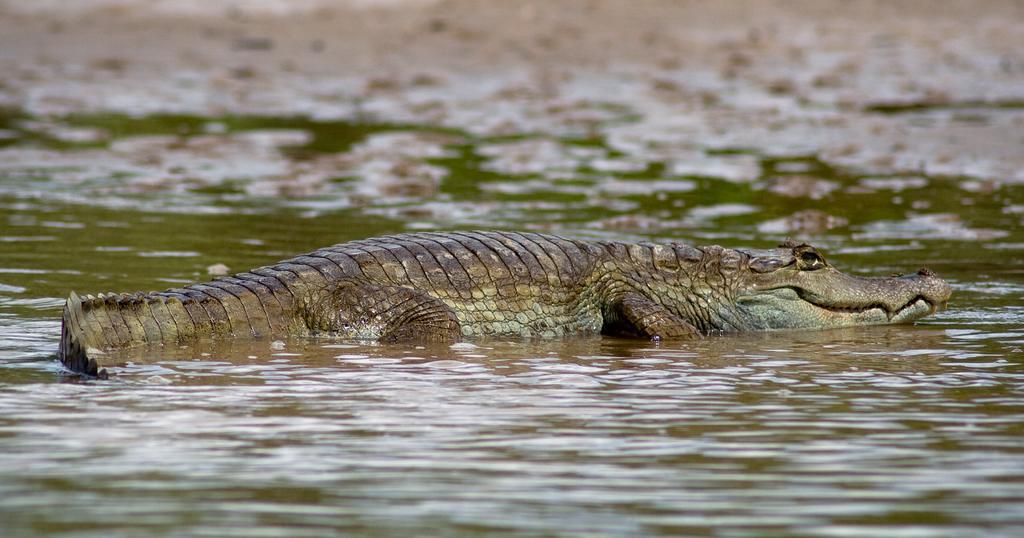Describe this image in one or two sentences. In this picture there is a crocodile in the center of the image, on the water and there is water around the area of the image. 